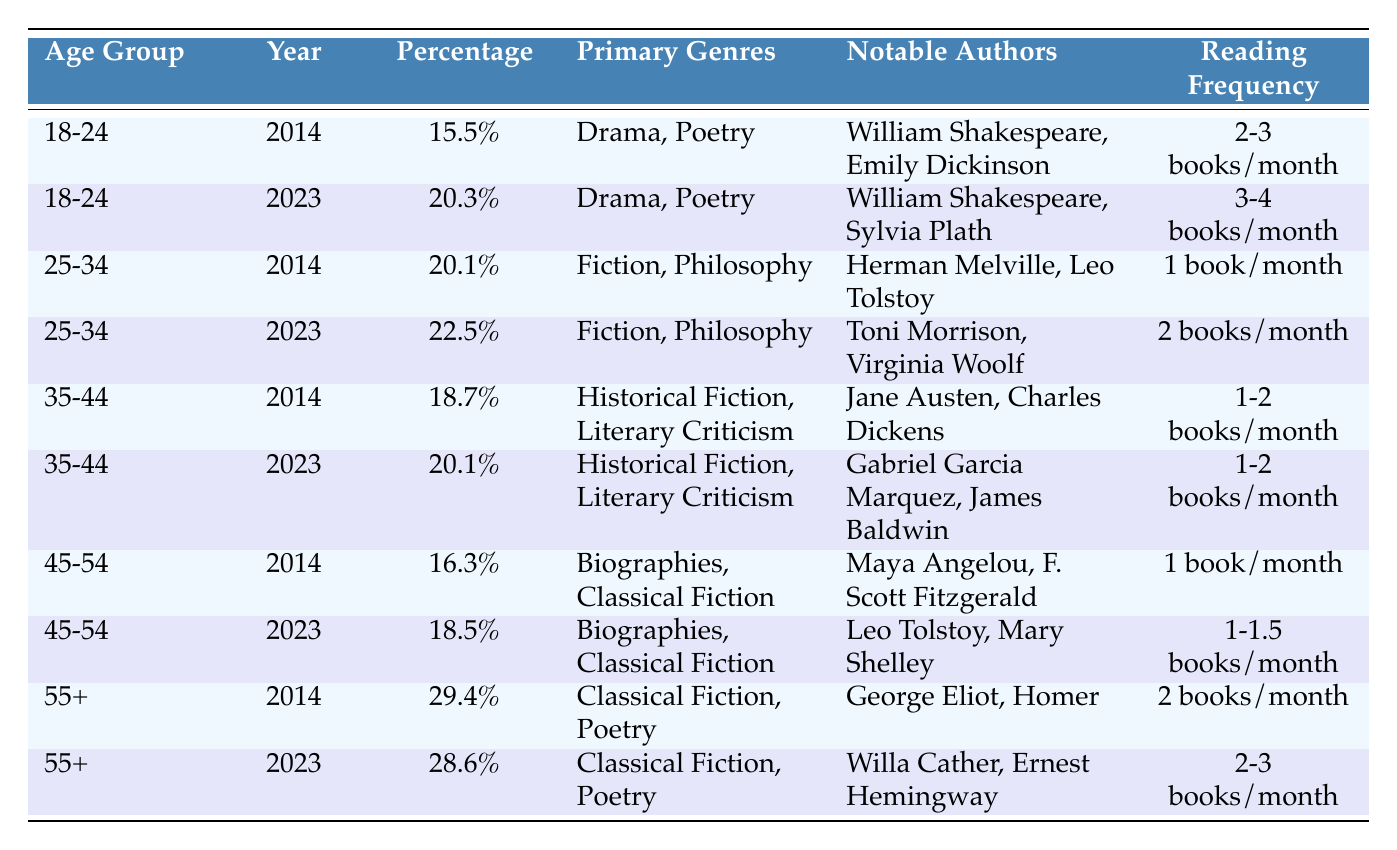What was the readership percentage for the age group 25-34 in 2014? The table shows the statistics for the year 2014, where the row corresponding to the age group 25-34 indicates a readership percentage of 20.1.
Answer: 20.1% Which age group had the highest percentage of readership in 2014? The highest readership percentage in 2014 can be found by comparing all the rows. The age group 55+ had the highest percentage at 29.4%.
Answer: 55+ Did the percentage of readers aged 18-24 increase from 2014 to 2023? By looking at the percentages for the age group 18-24, it was 15.5% in 2014 and increased to 20.3% in 2023. Therefore, it did increase.
Answer: Yes What is the reading frequency for the age group 45-54 in 2023? In the row for the age group 45-54 for the year 2023, the reading frequency is noted as 1-1.5 books/month.
Answer: 1-1.5 books/month What is the difference in percentage readership for the age group 55+ between 2014 and 2023? To find the difference, subtract the 2014 percentage (29.4%) from the 2023 percentage (28.6%). This results in 28.6% - 29.4% = -0.8%, indicating a decrease.
Answer: -0.8% Which notable authors were associated with the primary genres of Poetry for the age group 18-24 in 2023? The table lists the notable authors for the 18-24 age group in 2023, which includes William Shakespeare and Sylvia Plath under the primary genres of Drama and Poetry.
Answer: William Shakespeare, Sylvia Plath What was the average readership percentage across all age groups in 2023? Calculate the average by adding the percentages: (20.3 + 22.5 + 20.1 + 18.5 + 28.6) = 109.0, and then divide by 5 (the number of age groups), which equals 21.8%.
Answer: 21.8% Did the primary genres for the age group 35-44 remain the same from 2014 to 2023? Both in 2014 and 2023, the primary genres listed for the age group 35-44 are Historical Fiction and Literary Criticism, indicating no change.
Answer: Yes What was the notable author for the primary genre of Classical Fiction in 2014 for the age group 45-54? The row for the age group 45-54 in 2014 indicates Maya Angelou and F. Scott Fitzgerald as notable authors under Biographies and Classical Fiction.
Answer: Maya Angelou, F. Scott Fitzgerald 